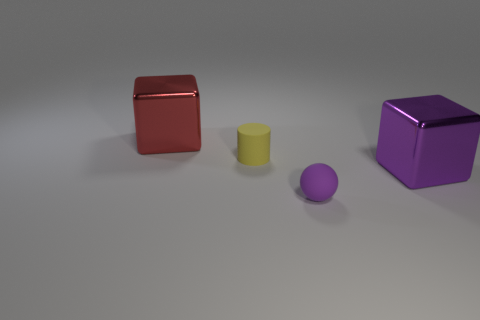Add 3 tiny purple rubber spheres. How many objects exist? 7 Subtract all cylinders. How many objects are left? 3 Add 3 large cyan metallic cylinders. How many large cyan metallic cylinders exist? 3 Subtract 0 green cylinders. How many objects are left? 4 Subtract all big purple metallic cubes. Subtract all tiny matte things. How many objects are left? 1 Add 2 red things. How many red things are left? 3 